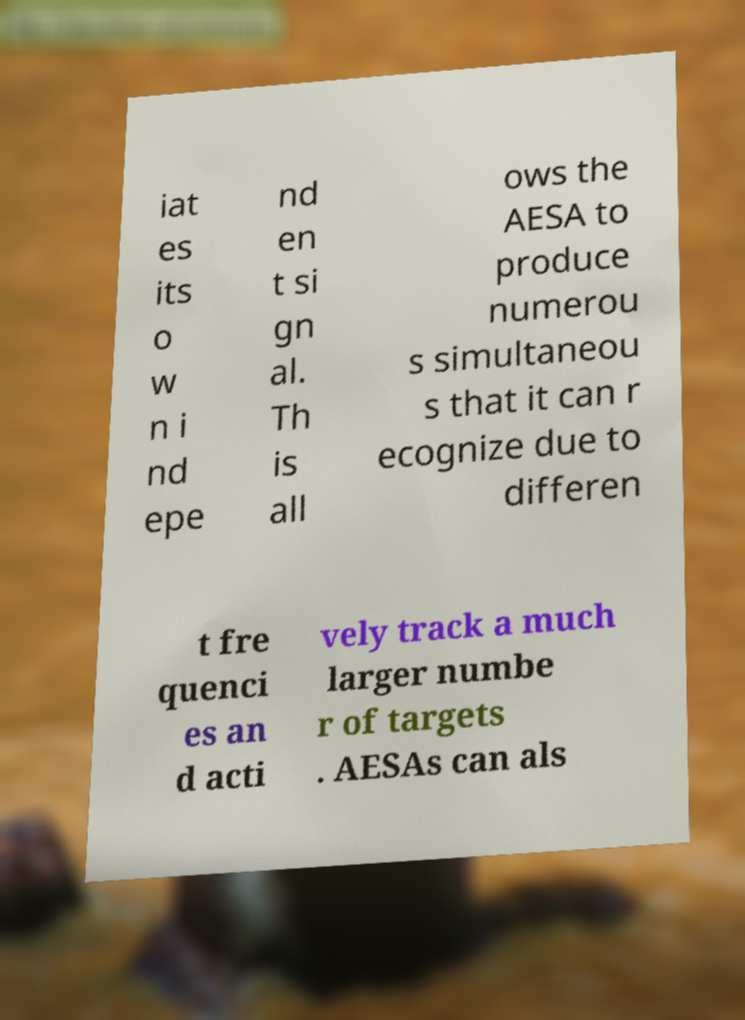Please read and relay the text visible in this image. What does it say? iat es its o w n i nd epe nd en t si gn al. Th is all ows the AESA to produce numerou s simultaneou s that it can r ecognize due to differen t fre quenci es an d acti vely track a much larger numbe r of targets . AESAs can als 